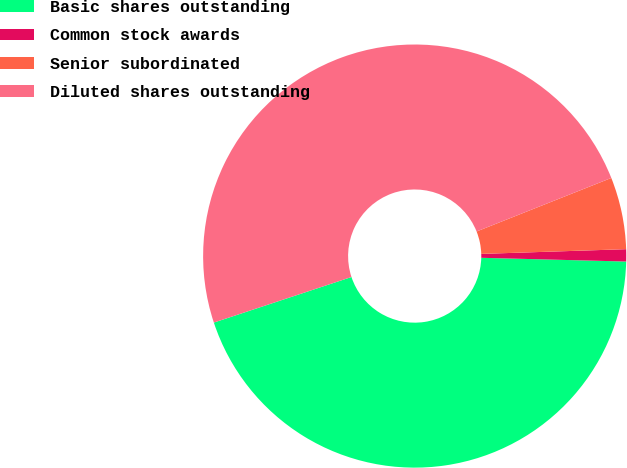Convert chart to OTSL. <chart><loc_0><loc_0><loc_500><loc_500><pie_chart><fcel>Basic shares outstanding<fcel>Common stock awards<fcel>Senior subordinated<fcel>Diluted shares outstanding<nl><fcel>44.5%<fcel>0.93%<fcel>5.5%<fcel>49.07%<nl></chart> 